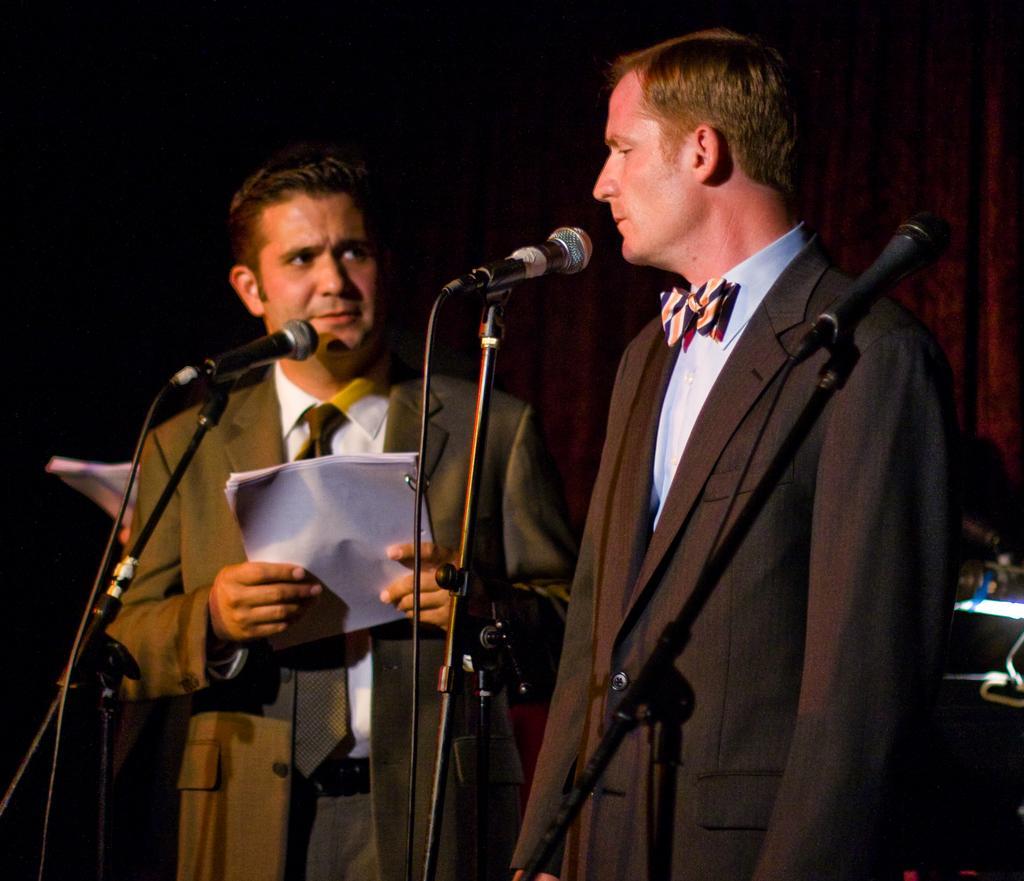Describe this image in one or two sentences. In this image we can see two persons are standing, in front of them there are three mics, both of them are wearing suits, and we can see a person is holding some papers. 